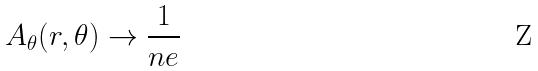Convert formula to latex. <formula><loc_0><loc_0><loc_500><loc_500>A _ { \theta } ( r , \theta ) \rightarrow \frac { 1 } { n e }</formula> 